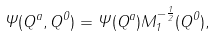<formula> <loc_0><loc_0><loc_500><loc_500>\Psi ( Q ^ { a } , Q ^ { 0 } ) = \Psi ( Q ^ { a } ) M _ { 1 } ^ { - \frac { 1 } { 2 } } ( Q ^ { 0 } ) ,</formula> 